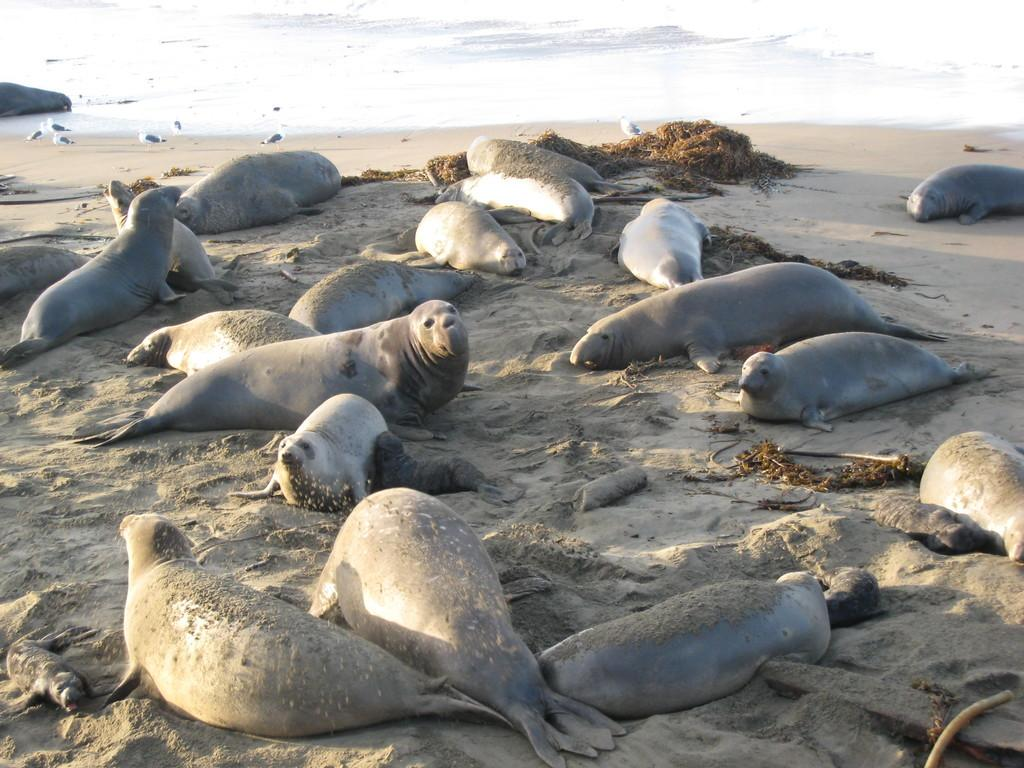What animals can be seen in the foreground of the picture? There are seals and birds in the foreground of the picture. What else is present in the foreground of the picture besides animals? There are other objects in the foreground of the picture. What can be seen in the background of the picture? There is a water body in the background of the picture. What type of badge is the farmer wearing while sitting on the chairs in the image? There is no farmer, badge, or chairs present in the image; it features seals, birds, and other objects in the foreground, with a water body in the background. 